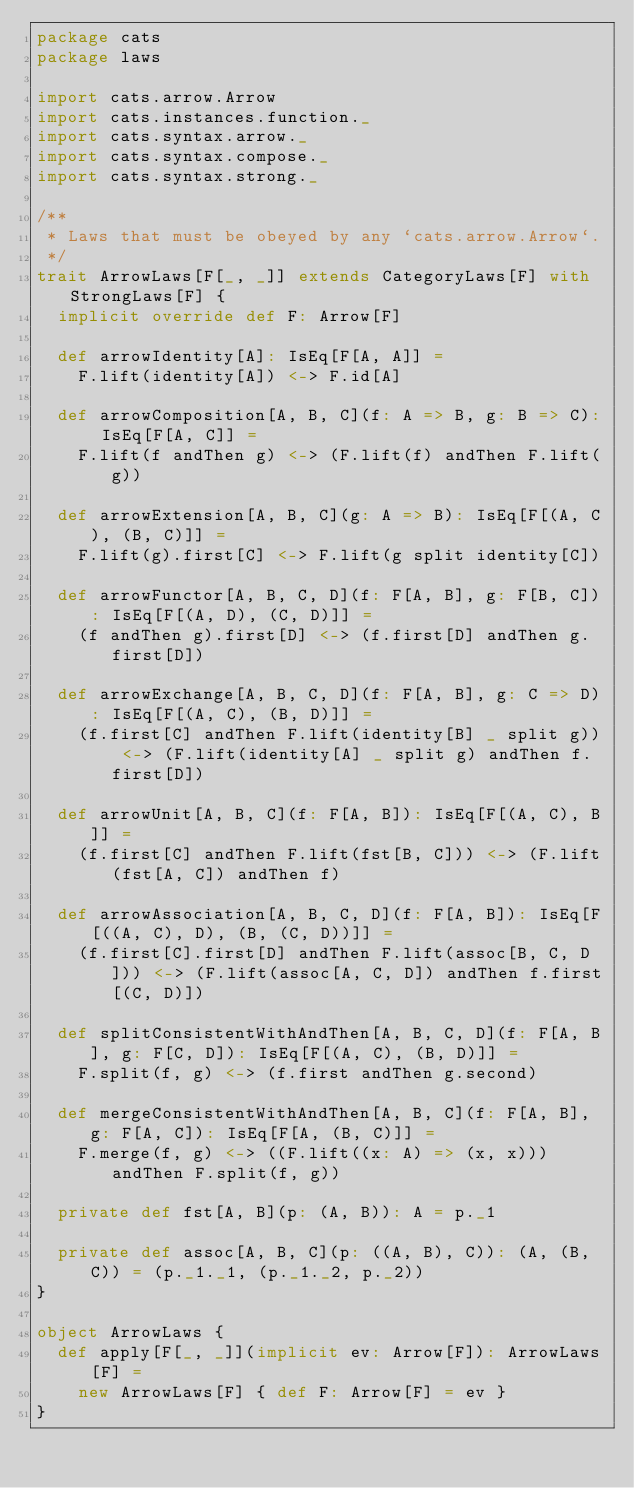<code> <loc_0><loc_0><loc_500><loc_500><_Scala_>package cats
package laws

import cats.arrow.Arrow
import cats.instances.function._
import cats.syntax.arrow._
import cats.syntax.compose._
import cats.syntax.strong._

/**
 * Laws that must be obeyed by any `cats.arrow.Arrow`.
 */
trait ArrowLaws[F[_, _]] extends CategoryLaws[F] with StrongLaws[F] {
  implicit override def F: Arrow[F]

  def arrowIdentity[A]: IsEq[F[A, A]] =
    F.lift(identity[A]) <-> F.id[A]

  def arrowComposition[A, B, C](f: A => B, g: B => C): IsEq[F[A, C]] =
    F.lift(f andThen g) <-> (F.lift(f) andThen F.lift(g))

  def arrowExtension[A, B, C](g: A => B): IsEq[F[(A, C), (B, C)]] =
    F.lift(g).first[C] <-> F.lift(g split identity[C])

  def arrowFunctor[A, B, C, D](f: F[A, B], g: F[B, C]): IsEq[F[(A, D), (C, D)]] =
    (f andThen g).first[D] <-> (f.first[D] andThen g.first[D])

  def arrowExchange[A, B, C, D](f: F[A, B], g: C => D): IsEq[F[(A, C), (B, D)]] =
    (f.first[C] andThen F.lift(identity[B] _ split g)) <-> (F.lift(identity[A] _ split g) andThen f.first[D])

  def arrowUnit[A, B, C](f: F[A, B]): IsEq[F[(A, C), B]] =
    (f.first[C] andThen F.lift(fst[B, C])) <-> (F.lift(fst[A, C]) andThen f)

  def arrowAssociation[A, B, C, D](f: F[A, B]): IsEq[F[((A, C), D), (B, (C, D))]] =
    (f.first[C].first[D] andThen F.lift(assoc[B, C, D])) <-> (F.lift(assoc[A, C, D]) andThen f.first[(C, D)])

  def splitConsistentWithAndThen[A, B, C, D](f: F[A, B], g: F[C, D]): IsEq[F[(A, C), (B, D)]] =
    F.split(f, g) <-> (f.first andThen g.second)

  def mergeConsistentWithAndThen[A, B, C](f: F[A, B], g: F[A, C]): IsEq[F[A, (B, C)]] =
    F.merge(f, g) <-> ((F.lift((x: A) => (x, x))) andThen F.split(f, g))

  private def fst[A, B](p: (A, B)): A = p._1

  private def assoc[A, B, C](p: ((A, B), C)): (A, (B, C)) = (p._1._1, (p._1._2, p._2))
}

object ArrowLaws {
  def apply[F[_, _]](implicit ev: Arrow[F]): ArrowLaws[F] =
    new ArrowLaws[F] { def F: Arrow[F] = ev }
}
</code> 